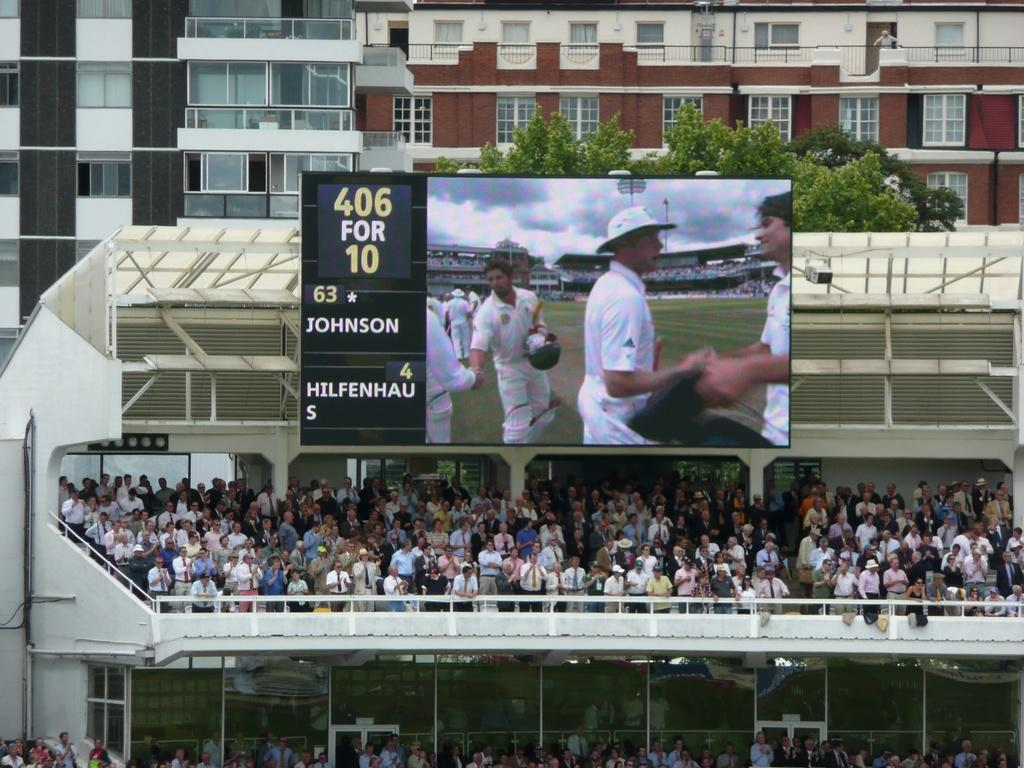<image>
Present a compact description of the photo's key features. The two people playing here are Johnson and Hilfenhau 